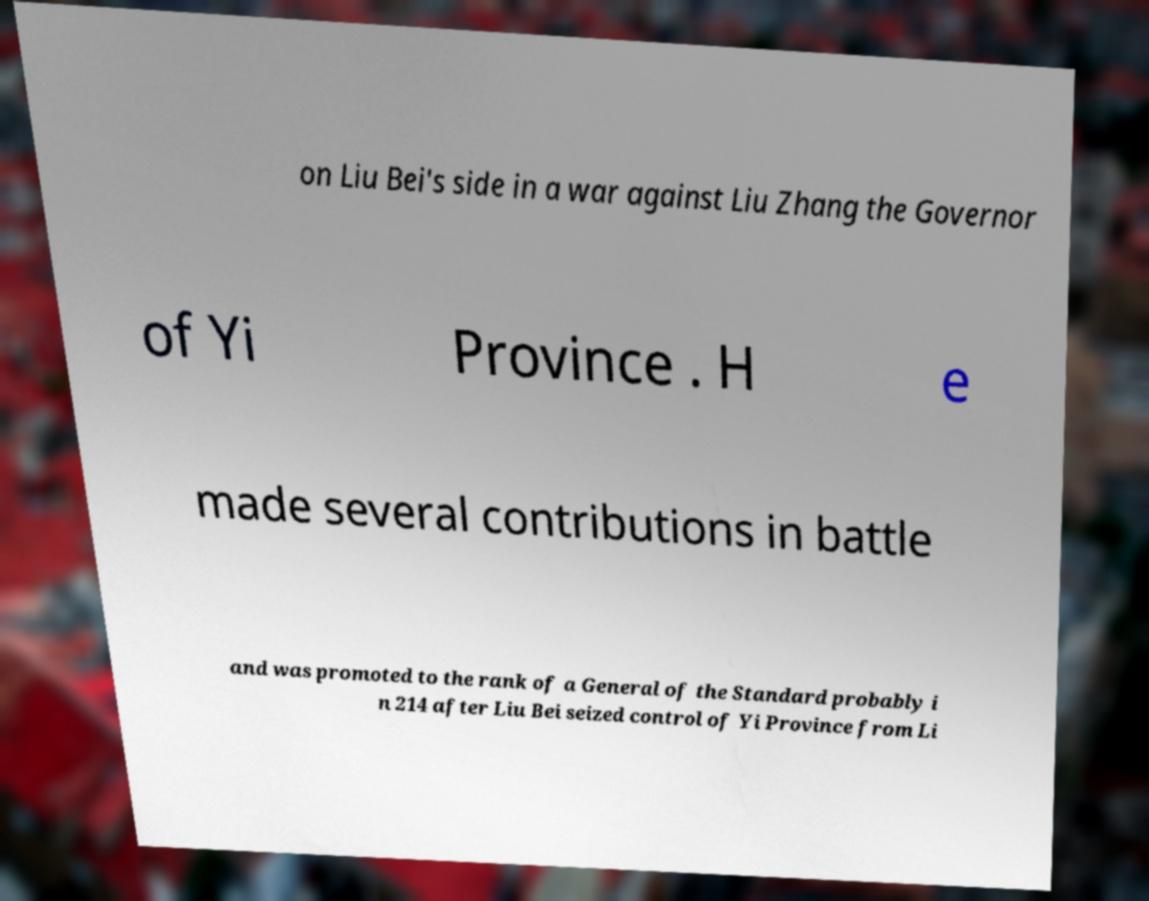For documentation purposes, I need the text within this image transcribed. Could you provide that? on Liu Bei's side in a war against Liu Zhang the Governor of Yi Province . H e made several contributions in battle and was promoted to the rank of a General of the Standard probably i n 214 after Liu Bei seized control of Yi Province from Li 